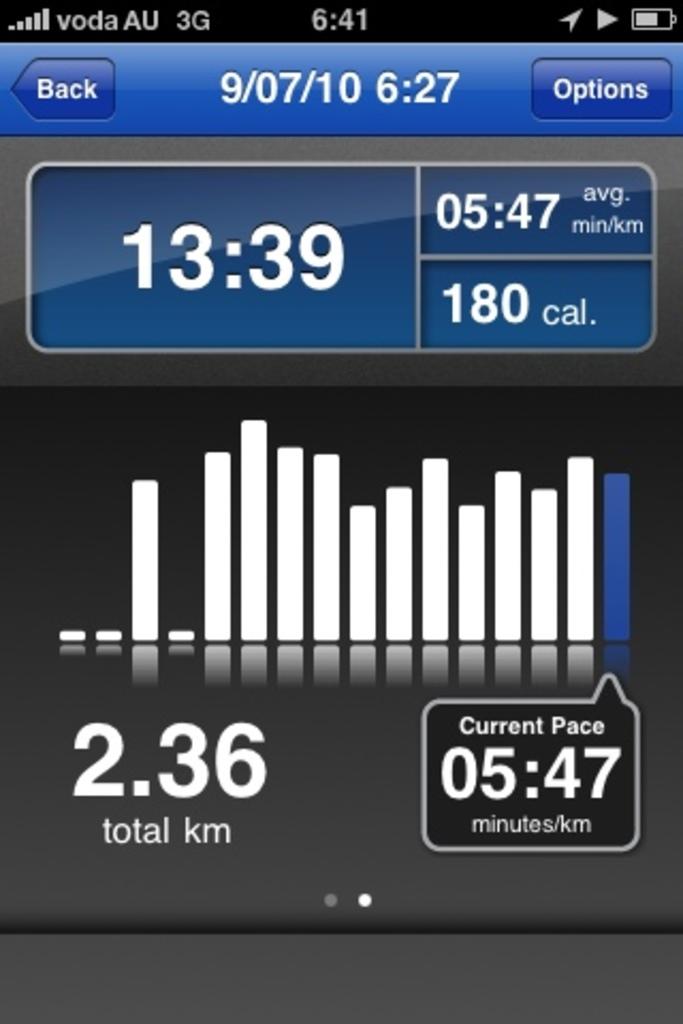Which network provider servicing this phone?
Give a very brief answer. Voda au. 